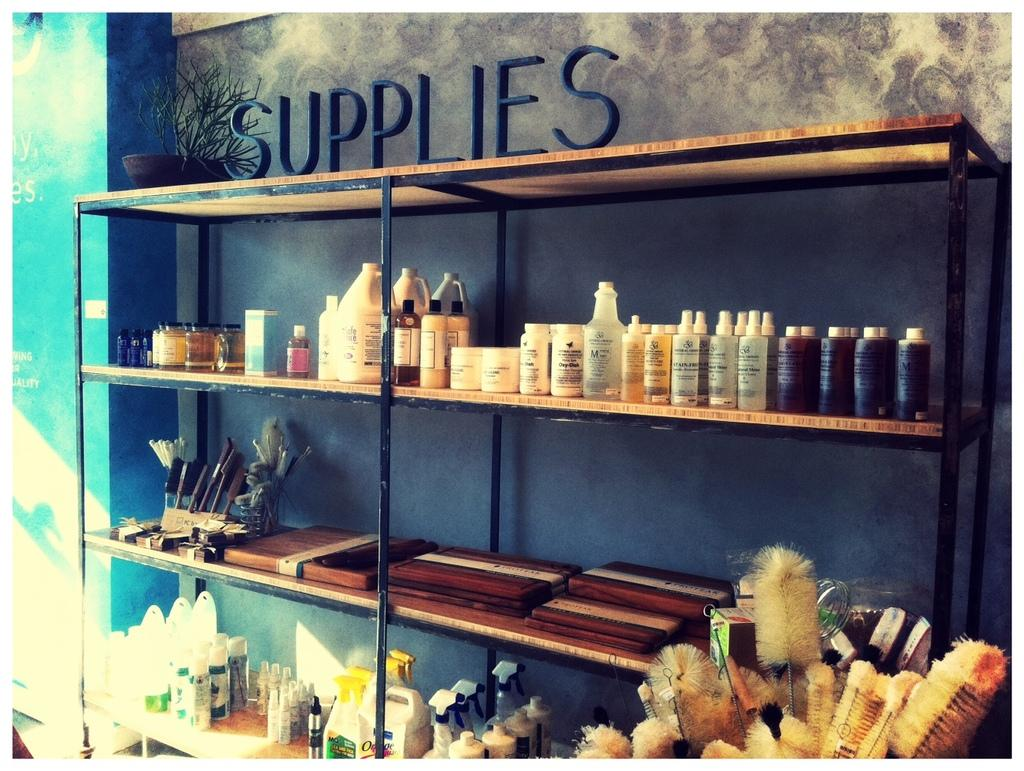Provide a one-sentence caption for the provided image. A supplies shelf with many different bottle on it. 